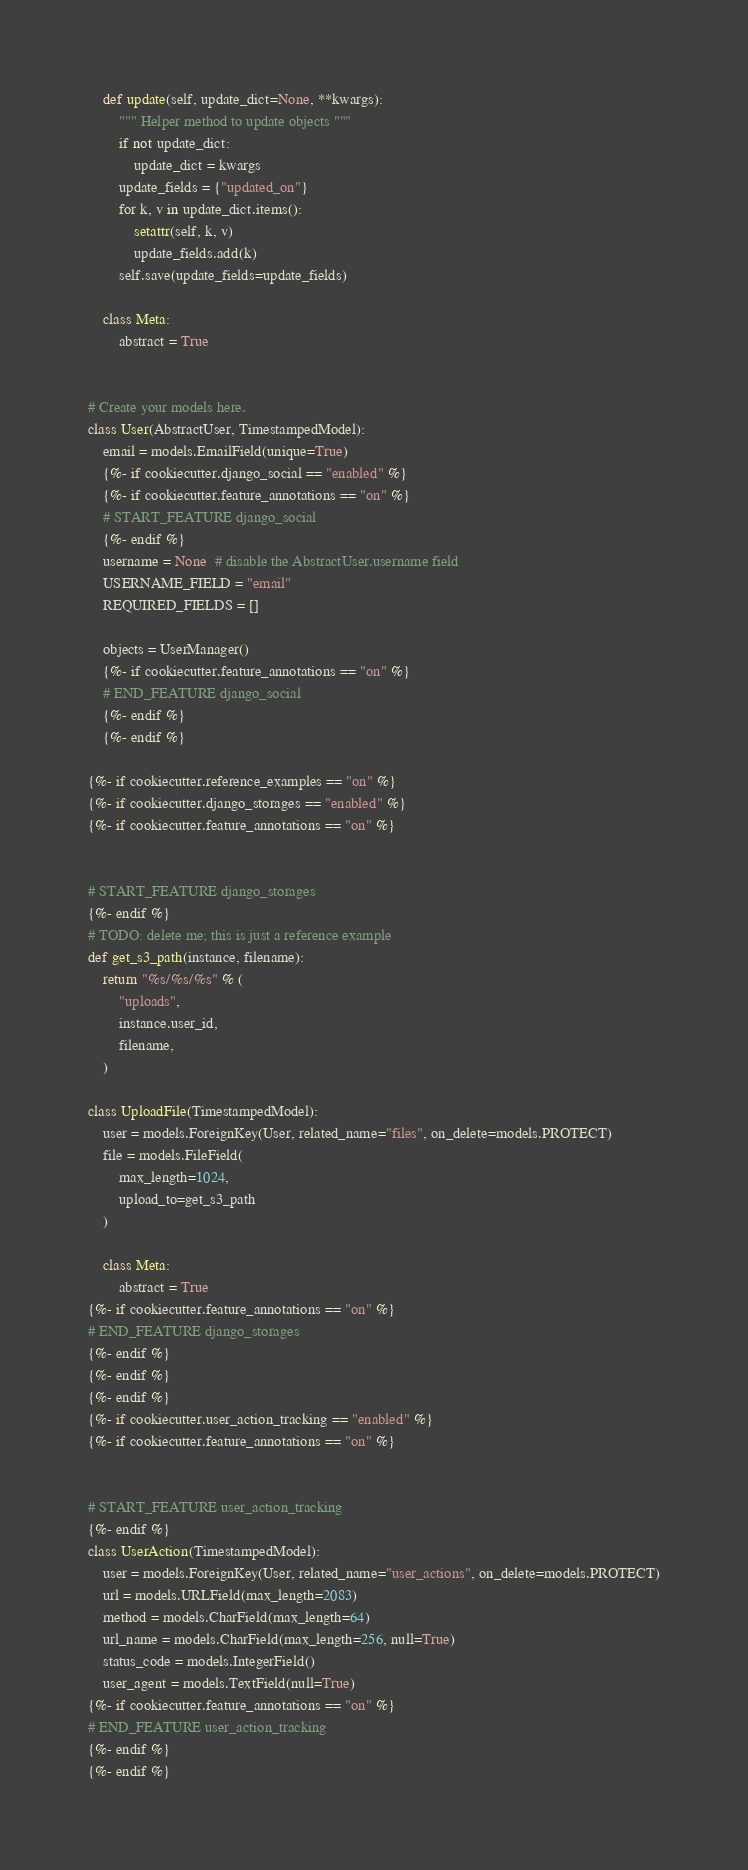Convert code to text. <code><loc_0><loc_0><loc_500><loc_500><_Python_>    def update(self, update_dict=None, **kwargs):
        """ Helper method to update objects """
        if not update_dict:
            update_dict = kwargs
        update_fields = {"updated_on"}
        for k, v in update_dict.items():
            setattr(self, k, v)
            update_fields.add(k)
        self.save(update_fields=update_fields)

    class Meta:
        abstract = True


# Create your models here.
class User(AbstractUser, TimestampedModel):
    email = models.EmailField(unique=True)
    {%- if cookiecutter.django_social == "enabled" %}
    {%- if cookiecutter.feature_annotations == "on" %}
    # START_FEATURE django_social
    {%- endif %}
    username = None  # disable the AbstractUser.username field
    USERNAME_FIELD = "email"
    REQUIRED_FIELDS = []

    objects = UserManager()
    {%- if cookiecutter.feature_annotations == "on" %}
    # END_FEATURE django_social
    {%- endif %}
    {%- endif %}

{%- if cookiecutter.reference_examples == "on" %}
{%- if cookiecutter.django_storages == "enabled" %}
{%- if cookiecutter.feature_annotations == "on" %}


# START_FEATURE django_storages
{%- endif %}
# TODO: delete me; this is just a reference example
def get_s3_path(instance, filename):
    return "%s/%s/%s" % (
        "uploads",
        instance.user_id,
        filename,
    )

class UploadFile(TimestampedModel):
    user = models.ForeignKey(User, related_name="files", on_delete=models.PROTECT)
    file = models.FileField(
        max_length=1024,
        upload_to=get_s3_path
    )

    class Meta:
        abstract = True
{%- if cookiecutter.feature_annotations == "on" %}
# END_FEATURE django_storages
{%- endif %}
{%- endif %}
{%- endif %}
{%- if cookiecutter.user_action_tracking == "enabled" %}
{%- if cookiecutter.feature_annotations == "on" %}


# START_FEATURE user_action_tracking
{%- endif %}
class UserAction(TimestampedModel):
    user = models.ForeignKey(User, related_name="user_actions", on_delete=models.PROTECT)
    url = models.URLField(max_length=2083)
    method = models.CharField(max_length=64)
    url_name = models.CharField(max_length=256, null=True)
    status_code = models.IntegerField()
    user_agent = models.TextField(null=True)
{%- if cookiecutter.feature_annotations == "on" %}
# END_FEATURE user_action_tracking
{%- endif %}
{%- endif %}
</code> 